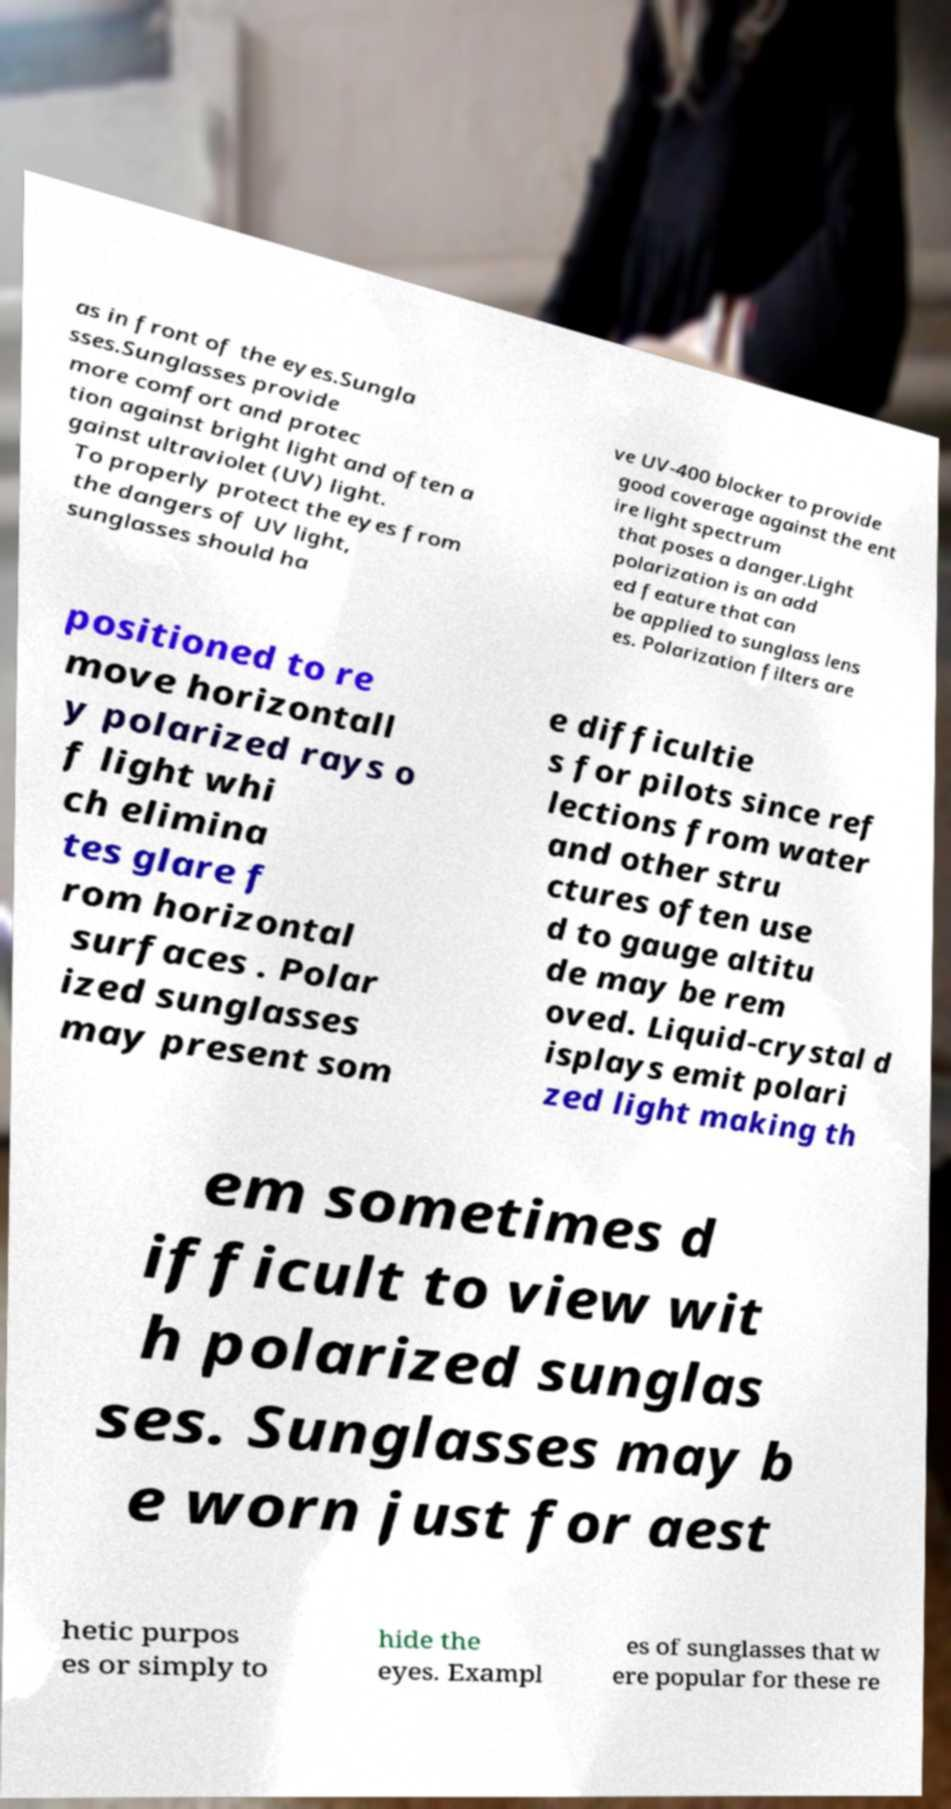Could you assist in decoding the text presented in this image and type it out clearly? as in front of the eyes.Sungla sses.Sunglasses provide more comfort and protec tion against bright light and often a gainst ultraviolet (UV) light. To properly protect the eyes from the dangers of UV light, sunglasses should ha ve UV-400 blocker to provide good coverage against the ent ire light spectrum that poses a danger.Light polarization is an add ed feature that can be applied to sunglass lens es. Polarization filters are positioned to re move horizontall y polarized rays o f light whi ch elimina tes glare f rom horizontal surfaces . Polar ized sunglasses may present som e difficultie s for pilots since ref lections from water and other stru ctures often use d to gauge altitu de may be rem oved. Liquid-crystal d isplays emit polari zed light making th em sometimes d ifficult to view wit h polarized sunglas ses. Sunglasses may b e worn just for aest hetic purpos es or simply to hide the eyes. Exampl es of sunglasses that w ere popular for these re 